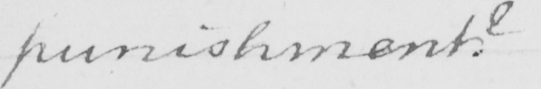Can you tell me what this handwritten text says? punishment ? 